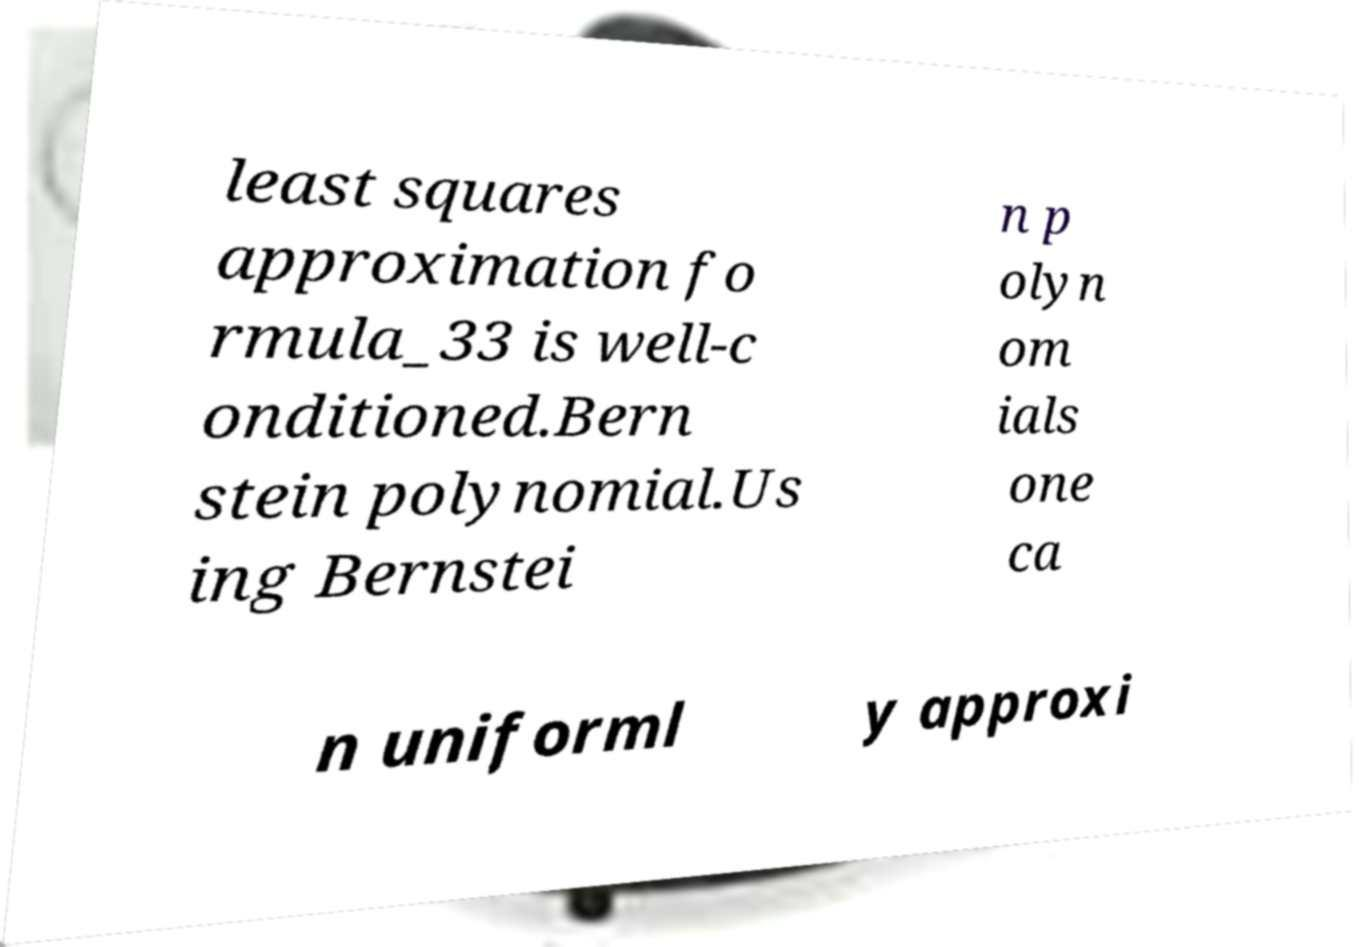For documentation purposes, I need the text within this image transcribed. Could you provide that? least squares approximation fo rmula_33 is well-c onditioned.Bern stein polynomial.Us ing Bernstei n p olyn om ials one ca n uniforml y approxi 